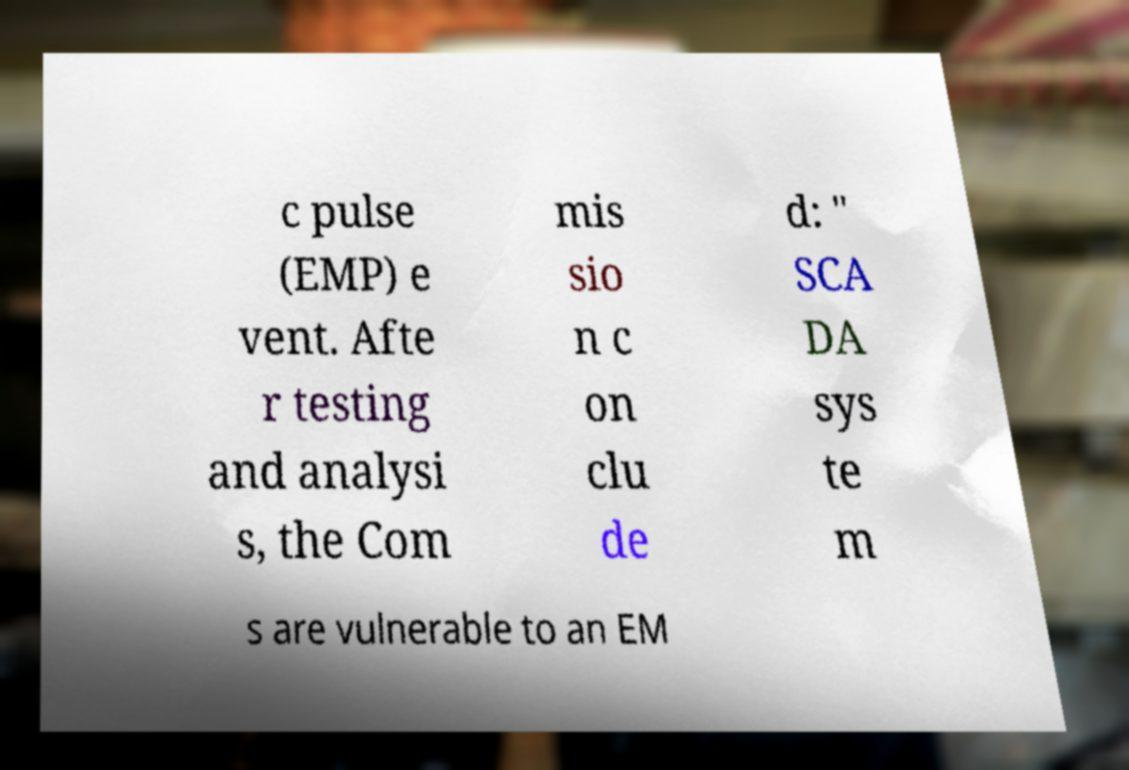Please read and relay the text visible in this image. What does it say? c pulse (EMP) e vent. Afte r testing and analysi s, the Com mis sio n c on clu de d: " SCA DA sys te m s are vulnerable to an EM 